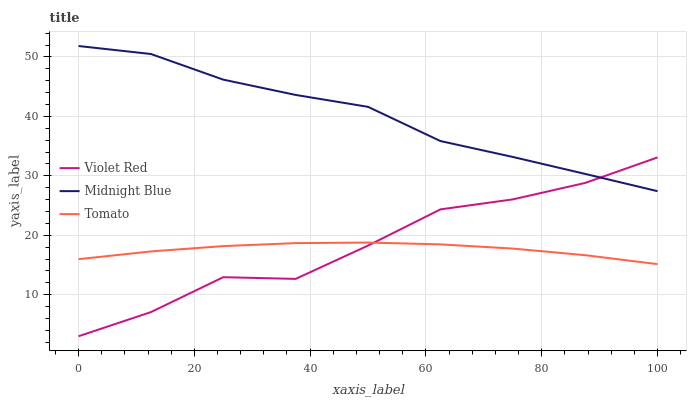Does Tomato have the minimum area under the curve?
Answer yes or no. Yes. Does Midnight Blue have the maximum area under the curve?
Answer yes or no. Yes. Does Violet Red have the minimum area under the curve?
Answer yes or no. No. Does Violet Red have the maximum area under the curve?
Answer yes or no. No. Is Tomato the smoothest?
Answer yes or no. Yes. Is Violet Red the roughest?
Answer yes or no. Yes. Is Midnight Blue the smoothest?
Answer yes or no. No. Is Midnight Blue the roughest?
Answer yes or no. No. Does Violet Red have the lowest value?
Answer yes or no. Yes. Does Midnight Blue have the lowest value?
Answer yes or no. No. Does Midnight Blue have the highest value?
Answer yes or no. Yes. Does Violet Red have the highest value?
Answer yes or no. No. Is Tomato less than Midnight Blue?
Answer yes or no. Yes. Is Midnight Blue greater than Tomato?
Answer yes or no. Yes. Does Violet Red intersect Midnight Blue?
Answer yes or no. Yes. Is Violet Red less than Midnight Blue?
Answer yes or no. No. Is Violet Red greater than Midnight Blue?
Answer yes or no. No. Does Tomato intersect Midnight Blue?
Answer yes or no. No. 